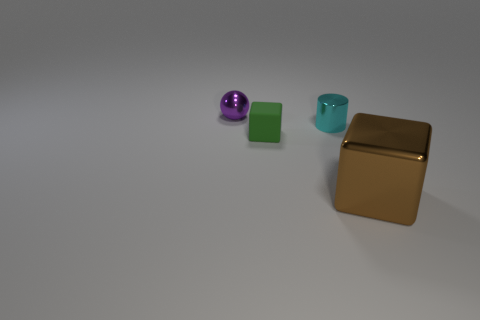Is there anything else that has the same material as the tiny green block?
Give a very brief answer. No. How many other things are there of the same size as the metallic block?
Provide a succinct answer. 0. Is there anything else that has the same shape as the purple metallic object?
Make the answer very short. No. Are there the same number of small green rubber objects on the right side of the cyan object and tiny green matte things?
Your answer should be very brief. No. How many big cubes are made of the same material as the small cube?
Offer a very short reply. 0. The cylinder that is the same material as the sphere is what color?
Your response must be concise. Cyan. Is the shape of the green matte object the same as the purple thing?
Your answer should be very brief. No. There is a cube that is left of the object that is right of the cylinder; are there any tiny objects on the left side of it?
Provide a short and direct response. Yes. What number of other metallic cylinders are the same color as the shiny cylinder?
Give a very brief answer. 0. What is the shape of the metal thing that is the same size as the cyan cylinder?
Offer a terse response. Sphere. 